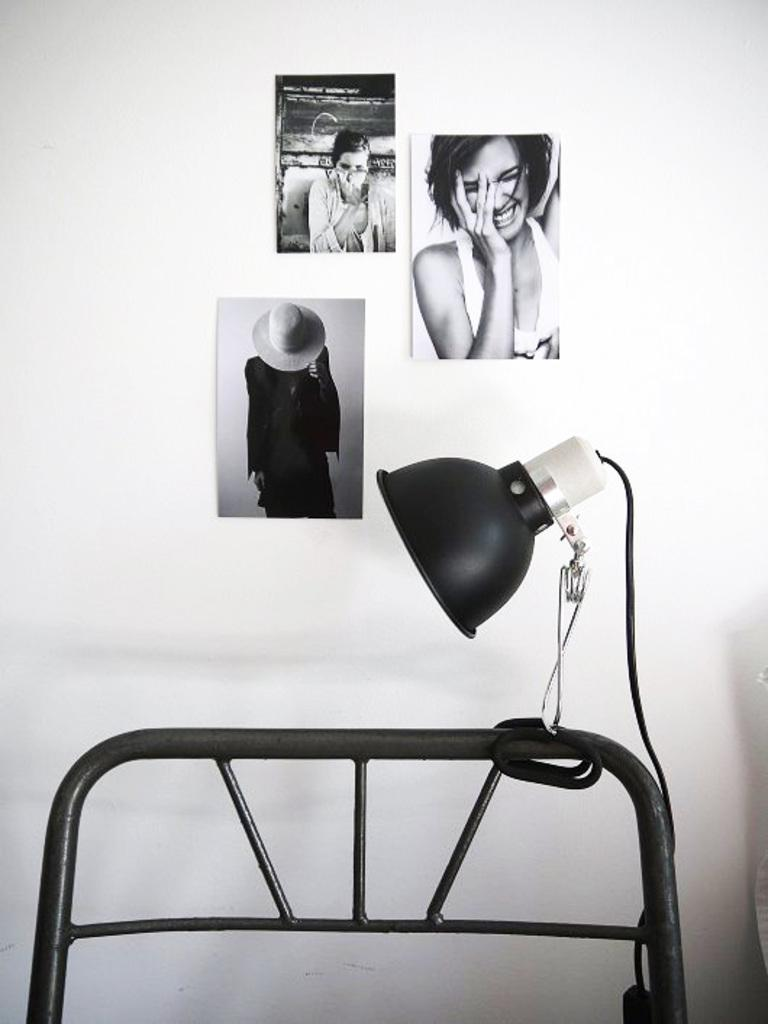What is the color scheme of the image? The image is black and white. What type of decorations are present in the image? There are wall hangings in the image. How are the wall hangings positioned in the image? The wall hangings attached to the wall. What type of lighting is visible in the image? There is a bed lamp in the image. Where is the bed lamp located in the image? The bed lamp is attached to a cot. What type of apparatus is used by the committee in the image? There is no apparatus or committee present in the image; it features wall hangings, a bed lamp, and a cot. What type of fowl can be seen in the image? There are no fowl present in the image. 